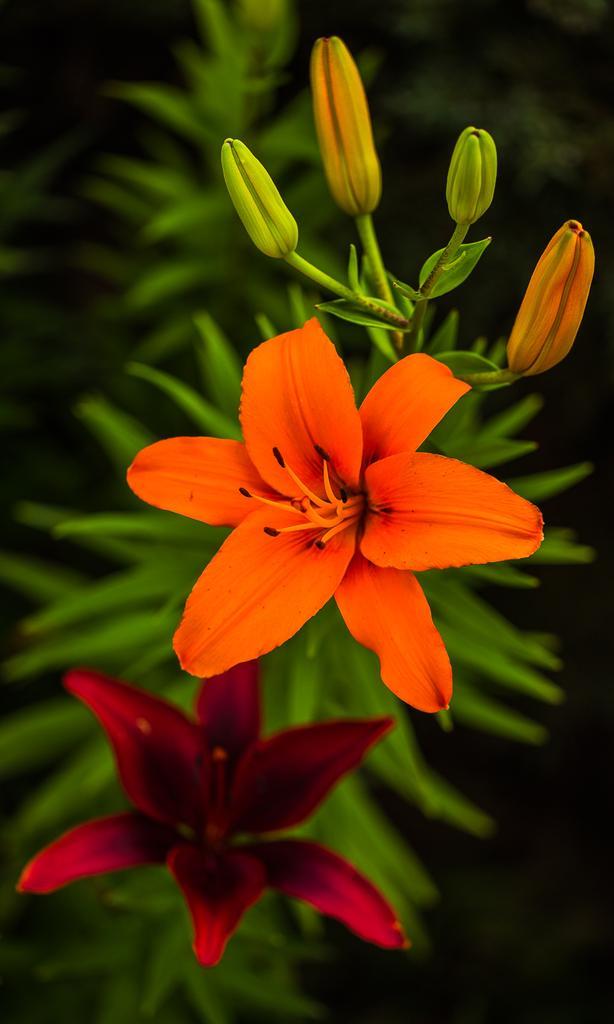In one or two sentences, can you explain what this image depicts? In this image there are flowers on a plant, behind the flowers there are leaves. 